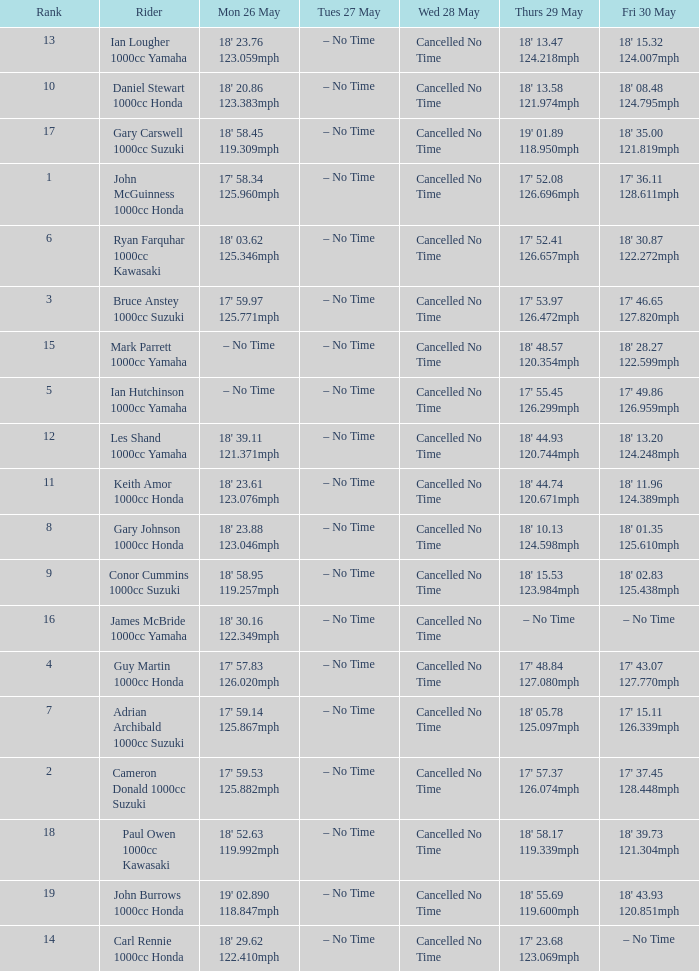What tims is wed may 28 and mon may 26 is 17' 58.34 125.960mph? Cancelled No Time. 